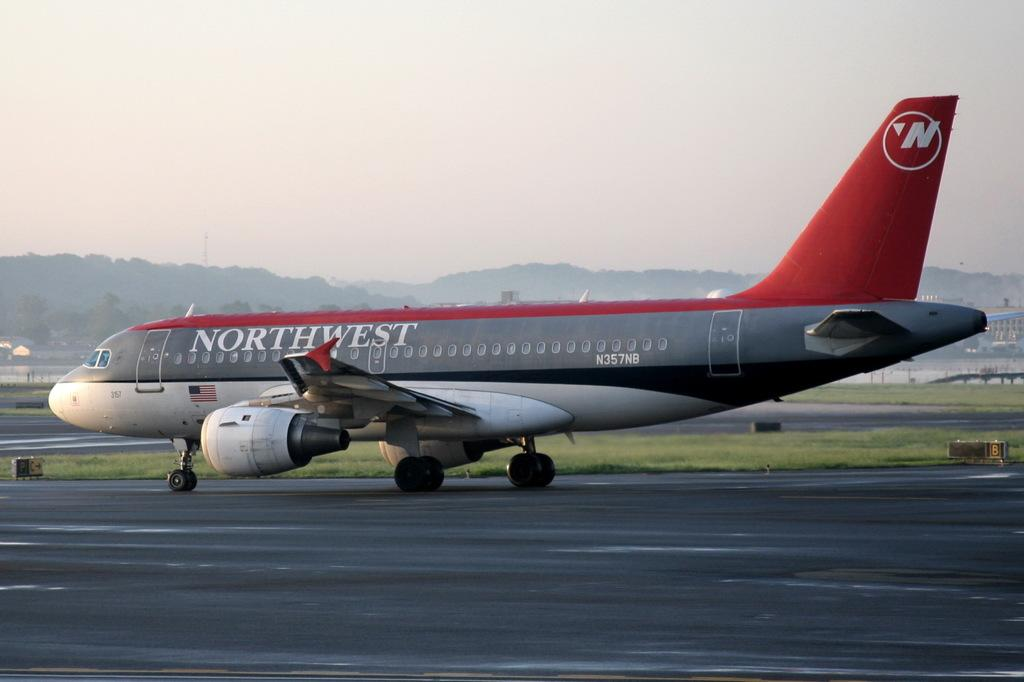<image>
Render a clear and concise summary of the photo. northwest airplane on the ramp ready to take off 